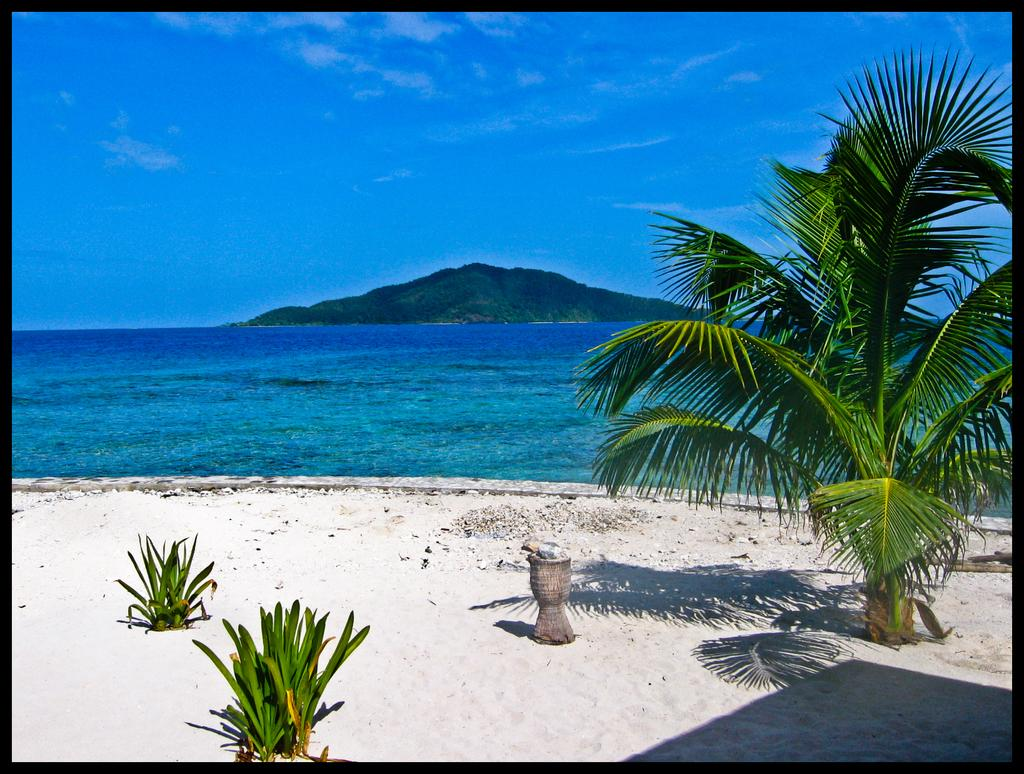What type of vegetation is present in the image? There are plants and trees in the image. What color are the plants and trees in the image? The plants and trees are green. What geographical feature can be seen in the image? There is a mountain in the image. What color is the sky in the image? The sky is blue. What type of humor can be seen in the image? There is no humor present in the image; it is a scene featuring plants, trees, a mountain, and a blue sky. 